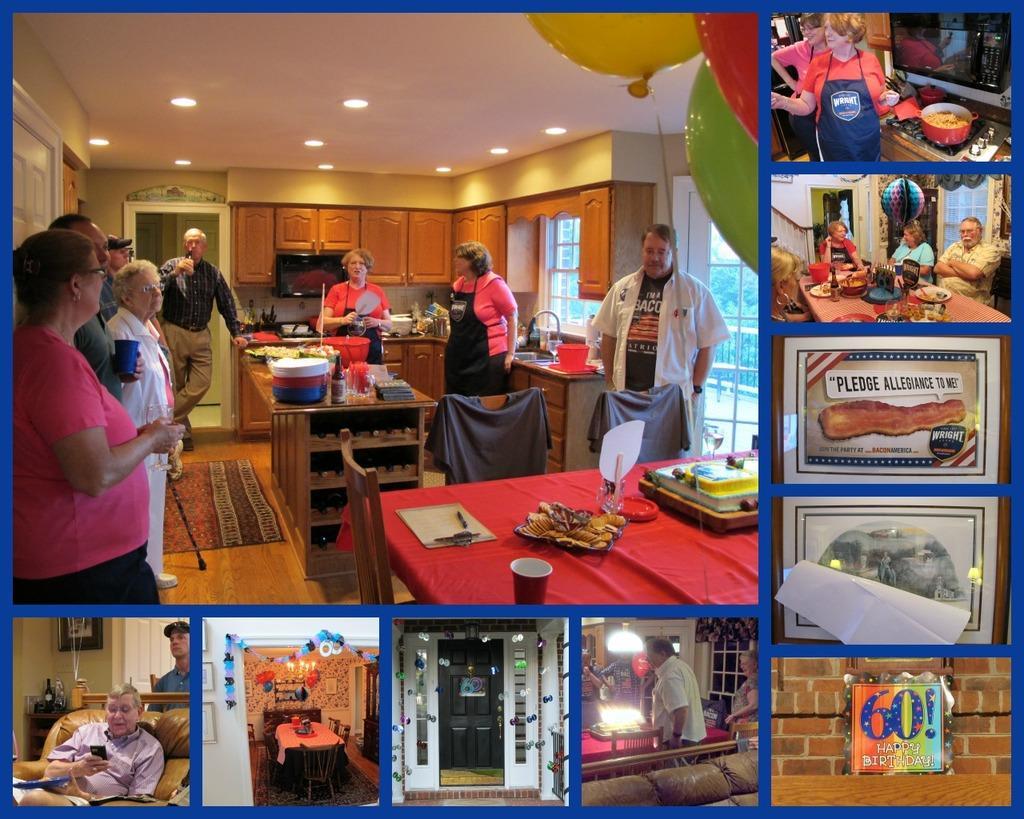Please provide a concise description of this image. On the top left, there is an image. In this image, there are persons in different color dresses, standing, there is a glass and other objects arranged on a table, there are chairs arranged, there are food items and other objects arranged on the table, which is in the kitchen, there are cupboards and there are lights attached to the roof. Around this image, there are nine images, which are having persons, posters and furniture. 